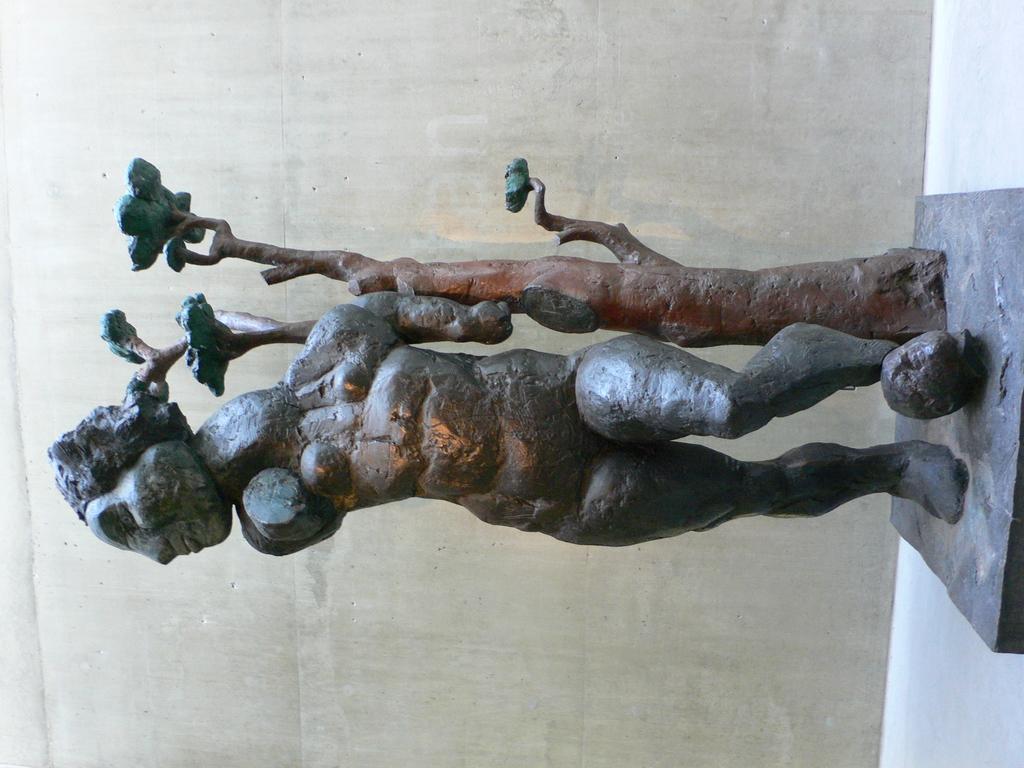Describe this image in one or two sentences. This image looks like the sculpture of a person and a tree with the leaves, which is placed on the stone. This looks like a wall. 